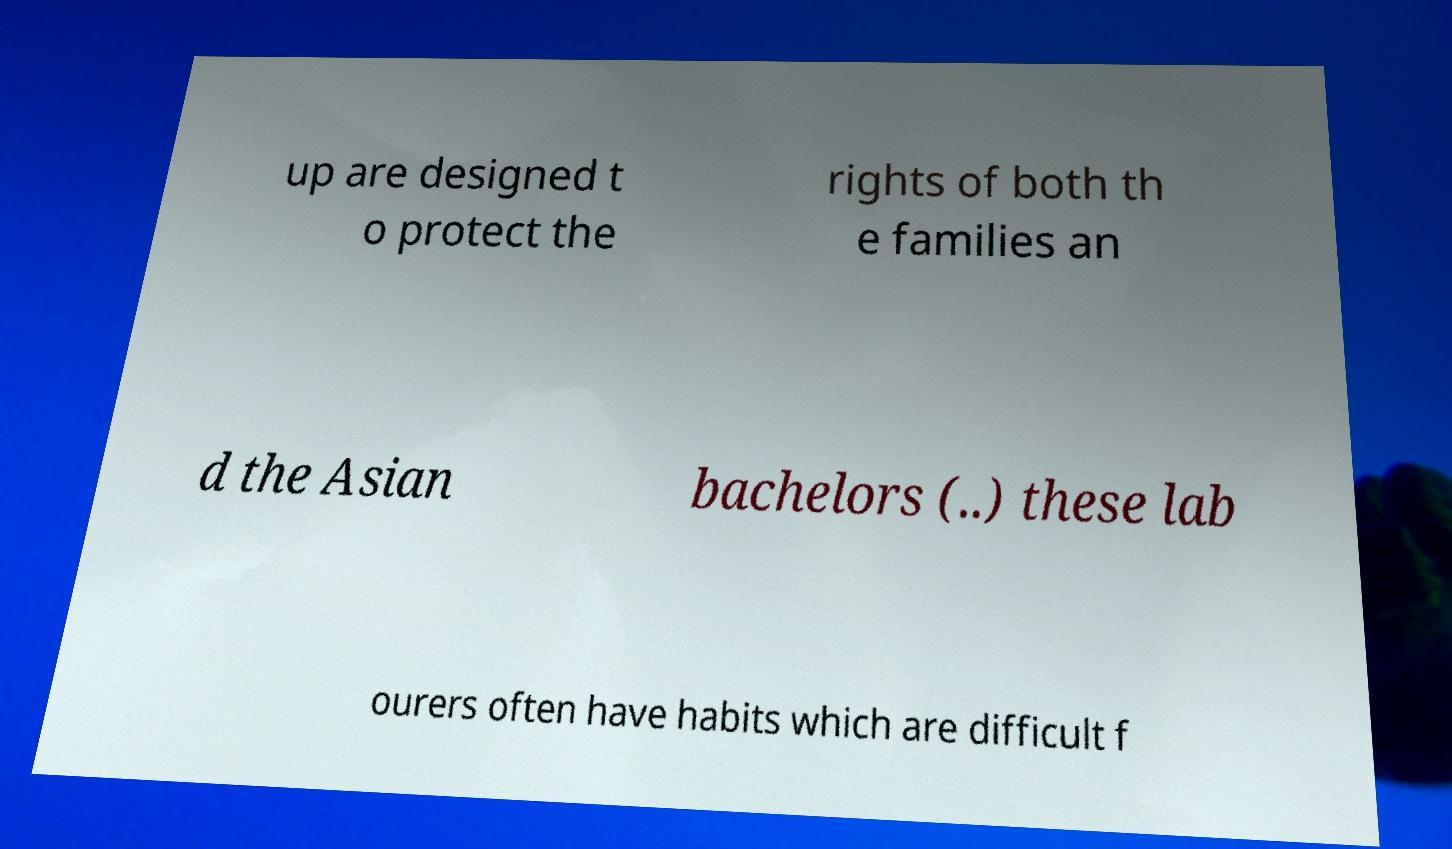Could you assist in decoding the text presented in this image and type it out clearly? up are designed t o protect the rights of both th e families an d the Asian bachelors (..) these lab ourers often have habits which are difficult f 